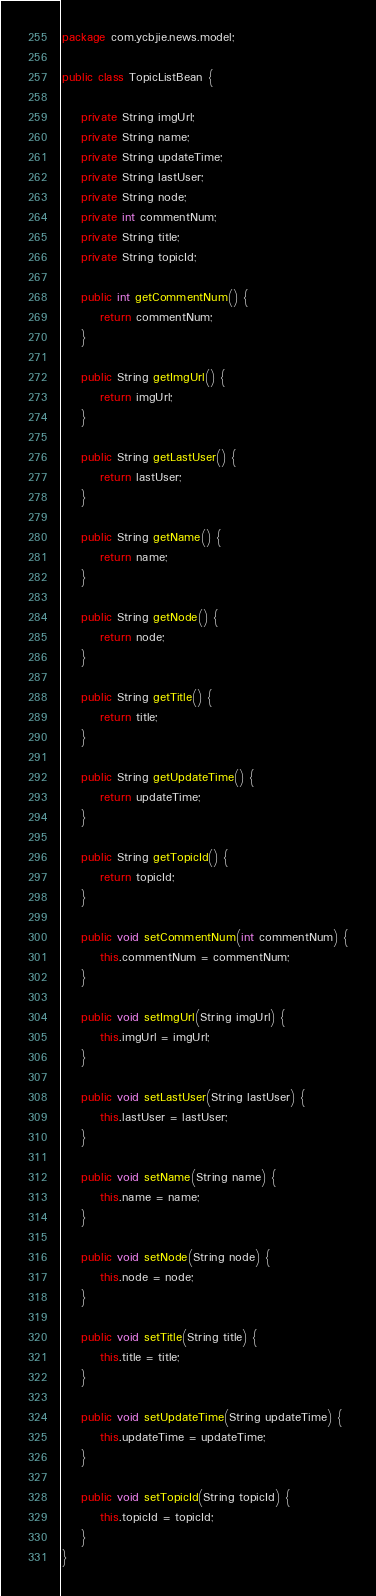<code> <loc_0><loc_0><loc_500><loc_500><_Java_>package com.ycbjie.news.model;

public class TopicListBean {

    private String imgUrl;
    private String name;
    private String updateTime;
    private String lastUser;
    private String node;
    private int commentNum;
    private String title;
    private String topicId;

    public int getCommentNum() {
        return commentNum;
    }

    public String getImgUrl() {
        return imgUrl;
    }

    public String getLastUser() {
        return lastUser;
    }

    public String getName() {
        return name;
    }

    public String getNode() {
        return node;
    }

    public String getTitle() {
        return title;
    }

    public String getUpdateTime() {
        return updateTime;
    }

    public String getTopicId() {
        return topicId;
    }

    public void setCommentNum(int commentNum) {
        this.commentNum = commentNum;
    }

    public void setImgUrl(String imgUrl) {
        this.imgUrl = imgUrl;
    }

    public void setLastUser(String lastUser) {
        this.lastUser = lastUser;
    }

    public void setName(String name) {
        this.name = name;
    }

    public void setNode(String node) {
        this.node = node;
    }

    public void setTitle(String title) {
        this.title = title;
    }

    public void setUpdateTime(String updateTime) {
        this.updateTime = updateTime;
    }

    public void setTopicId(String topicId) {
        this.topicId = topicId;
    }
}
</code> 